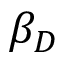<formula> <loc_0><loc_0><loc_500><loc_500>\beta _ { D }</formula> 